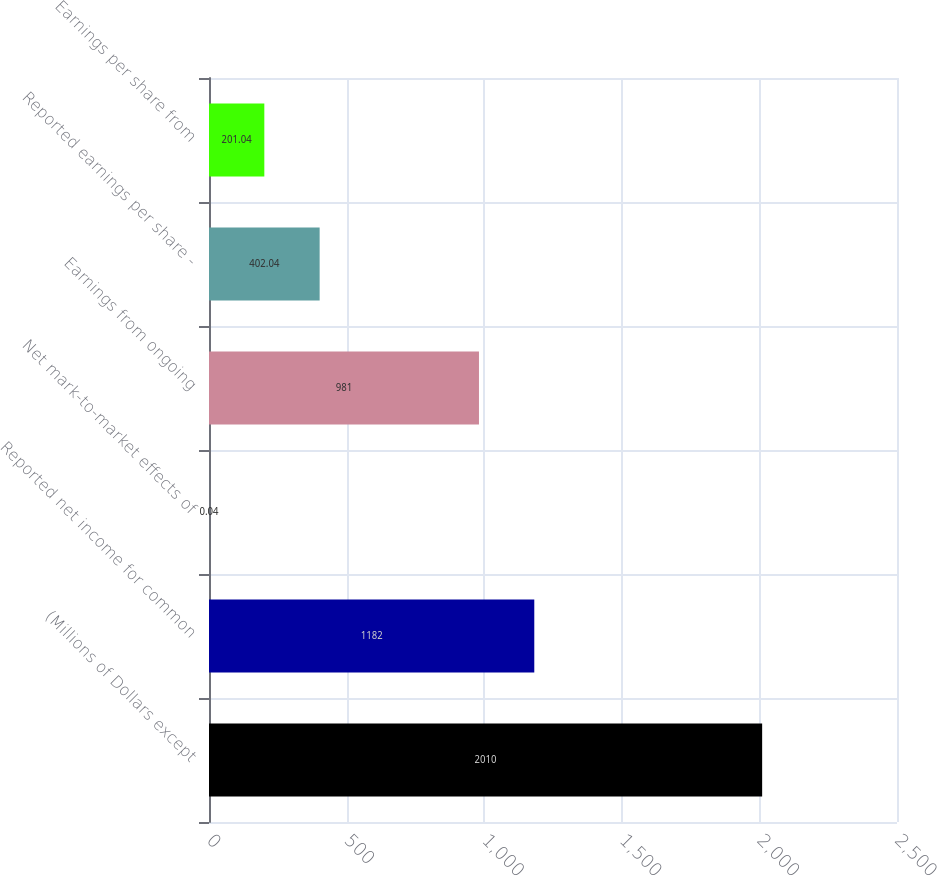Convert chart. <chart><loc_0><loc_0><loc_500><loc_500><bar_chart><fcel>(Millions of Dollars except<fcel>Reported net income for common<fcel>Net mark-to-market effects of<fcel>Earnings from ongoing<fcel>Reported earnings per share -<fcel>Earnings per share from<nl><fcel>2010<fcel>1182<fcel>0.04<fcel>981<fcel>402.04<fcel>201.04<nl></chart> 